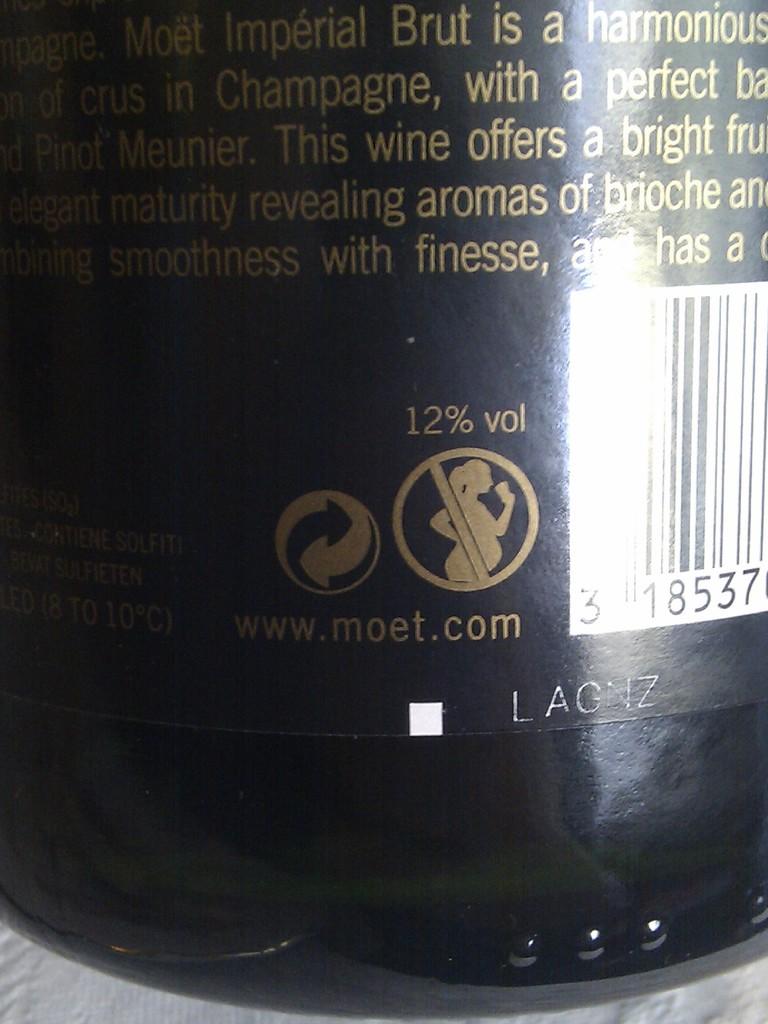What website can a consumer visit to learn more?
Ensure brevity in your answer.  Www.moet.com. What percent alcohol is this wine?
Your answer should be compact. 12%. 